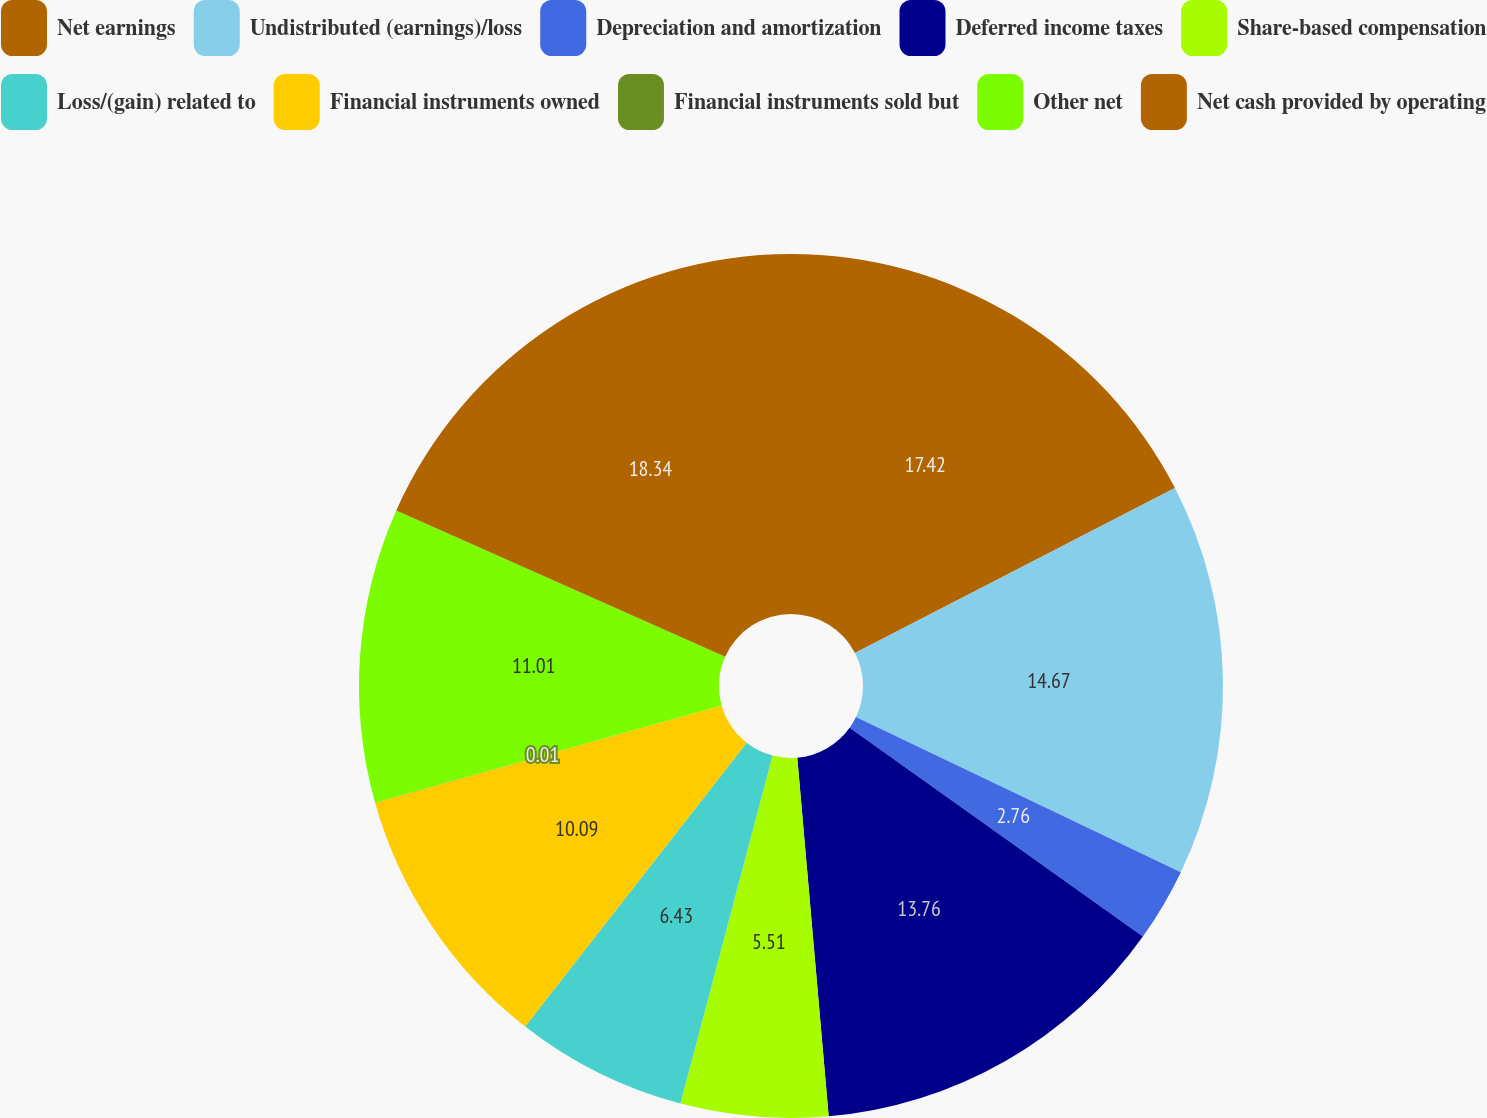<chart> <loc_0><loc_0><loc_500><loc_500><pie_chart><fcel>Net earnings<fcel>Undistributed (earnings)/loss<fcel>Depreciation and amortization<fcel>Deferred income taxes<fcel>Share-based compensation<fcel>Loss/(gain) related to<fcel>Financial instruments owned<fcel>Financial instruments sold but<fcel>Other net<fcel>Net cash provided by operating<nl><fcel>17.42%<fcel>14.67%<fcel>2.76%<fcel>13.76%<fcel>5.51%<fcel>6.43%<fcel>10.09%<fcel>0.01%<fcel>11.01%<fcel>18.34%<nl></chart> 